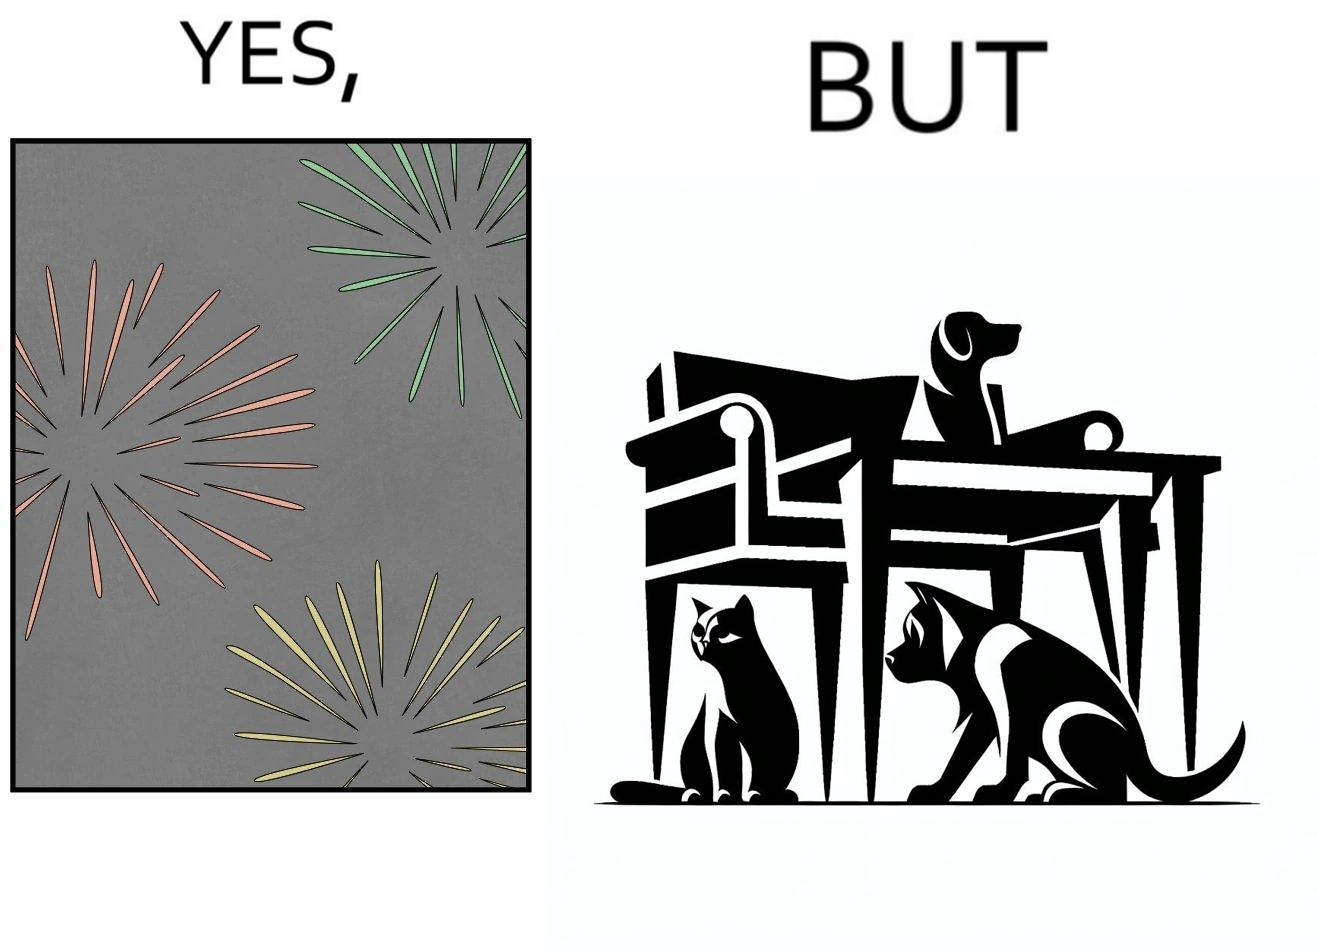Provide a description of this image. The image is satirical because while firecrackers in the sky look pretty, not everyone likes them. Animals are very scared of the firecrackers. 